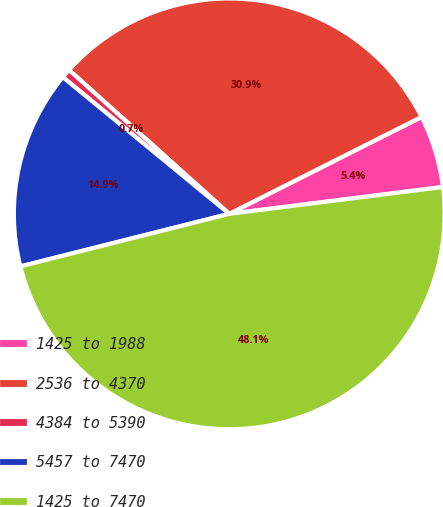<chart> <loc_0><loc_0><loc_500><loc_500><pie_chart><fcel>1425 to 1988<fcel>2536 to 4370<fcel>4384 to 5390<fcel>5457 to 7470<fcel>1425 to 7470<nl><fcel>5.44%<fcel>30.93%<fcel>0.7%<fcel>14.87%<fcel>48.07%<nl></chart> 